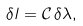<formula> <loc_0><loc_0><loc_500><loc_500>\delta l = \mathcal { C } \, \delta \lambda ,</formula> 